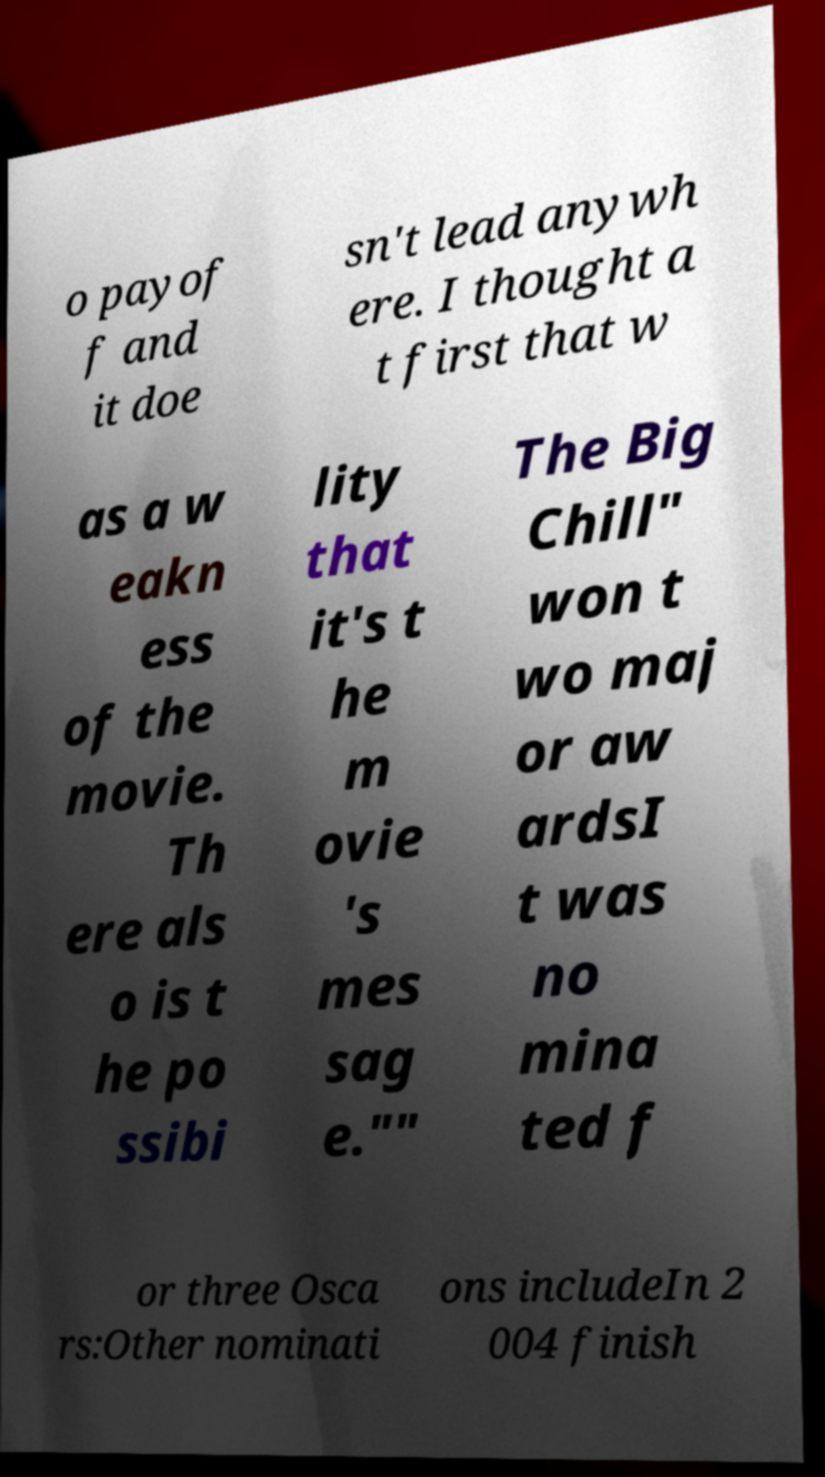For documentation purposes, I need the text within this image transcribed. Could you provide that? o payof f and it doe sn't lead anywh ere. I thought a t first that w as a w eakn ess of the movie. Th ere als o is t he po ssibi lity that it's t he m ovie 's mes sag e."" The Big Chill" won t wo maj or aw ardsI t was no mina ted f or three Osca rs:Other nominati ons includeIn 2 004 finish 